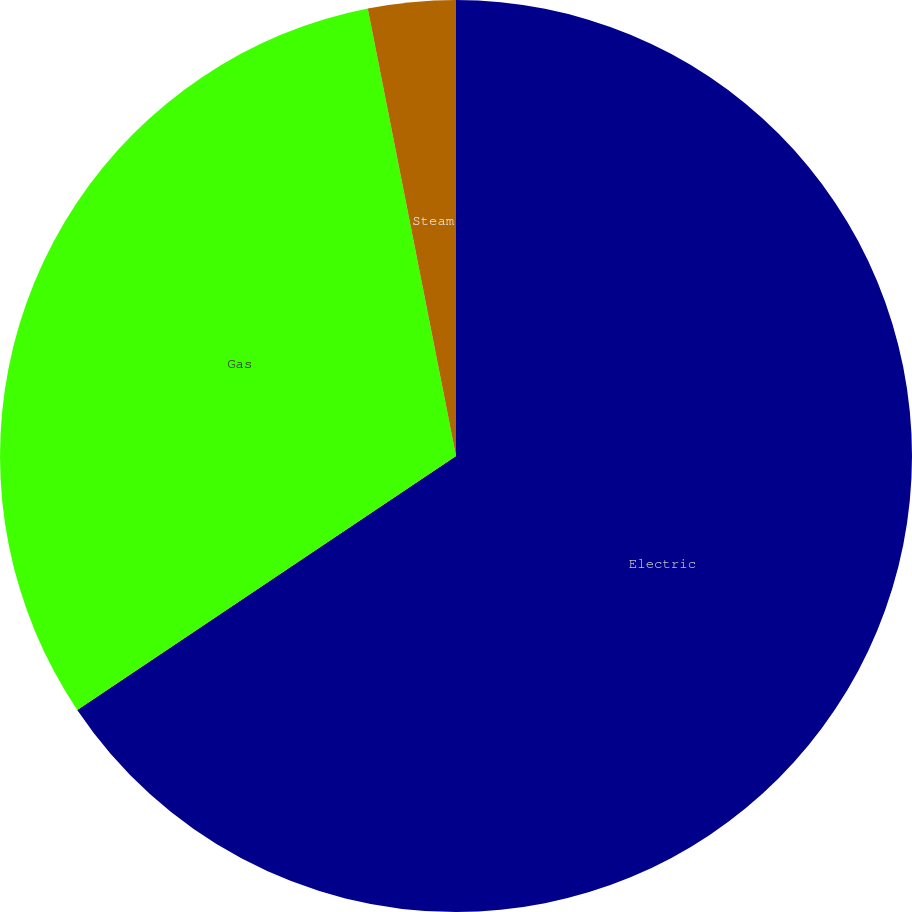Convert chart. <chart><loc_0><loc_0><loc_500><loc_500><pie_chart><fcel>Electric<fcel>Gas<fcel>Steam<nl><fcel>65.6%<fcel>31.3%<fcel>3.1%<nl></chart> 